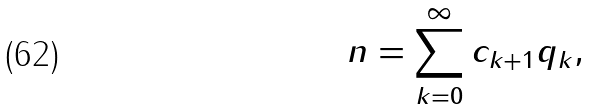Convert formula to latex. <formula><loc_0><loc_0><loc_500><loc_500>n = \sum _ { k = 0 } ^ { \infty } c _ { k + 1 } q _ { k } ,</formula> 